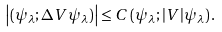Convert formula to latex. <formula><loc_0><loc_0><loc_500><loc_500>\left | ( \psi _ { \lambda } ; \Delta V \psi _ { \lambda } ) \right | \leq C \, ( \psi _ { \lambda } ; | V | \psi _ { \lambda } ) \, .</formula> 